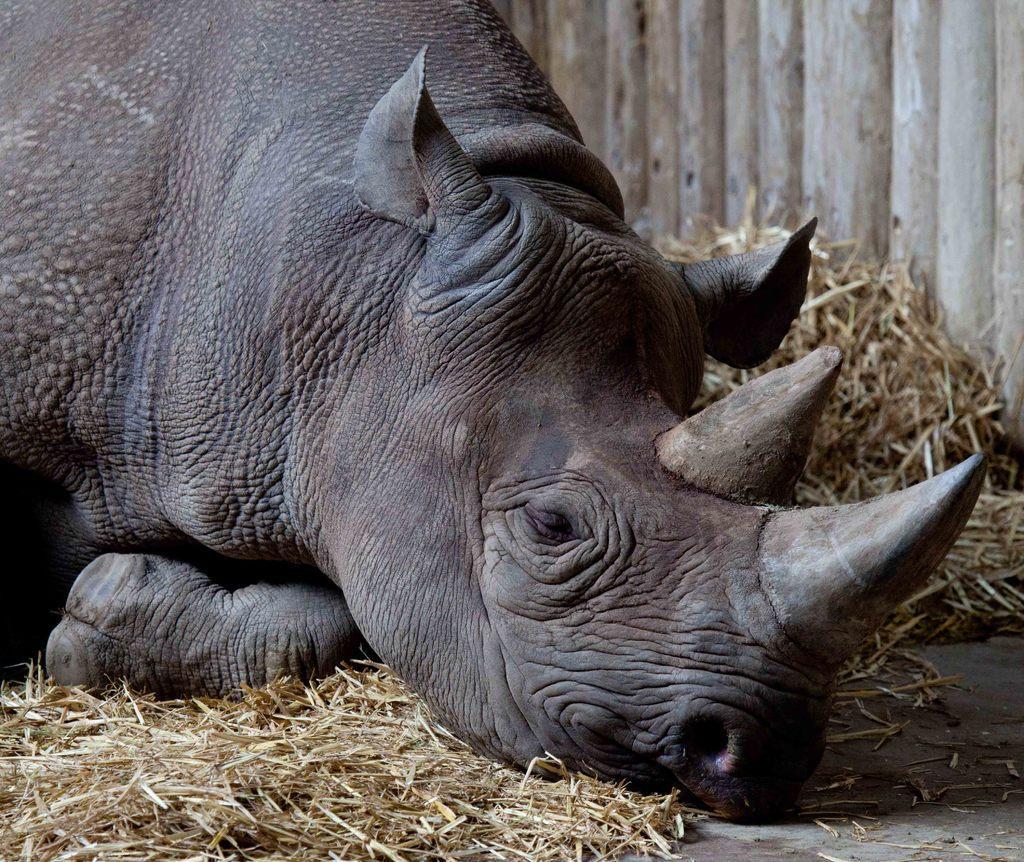In one or two sentences, can you explain what this image depicts? In this picture we can see hippopotamus is laying on the dry grass. 